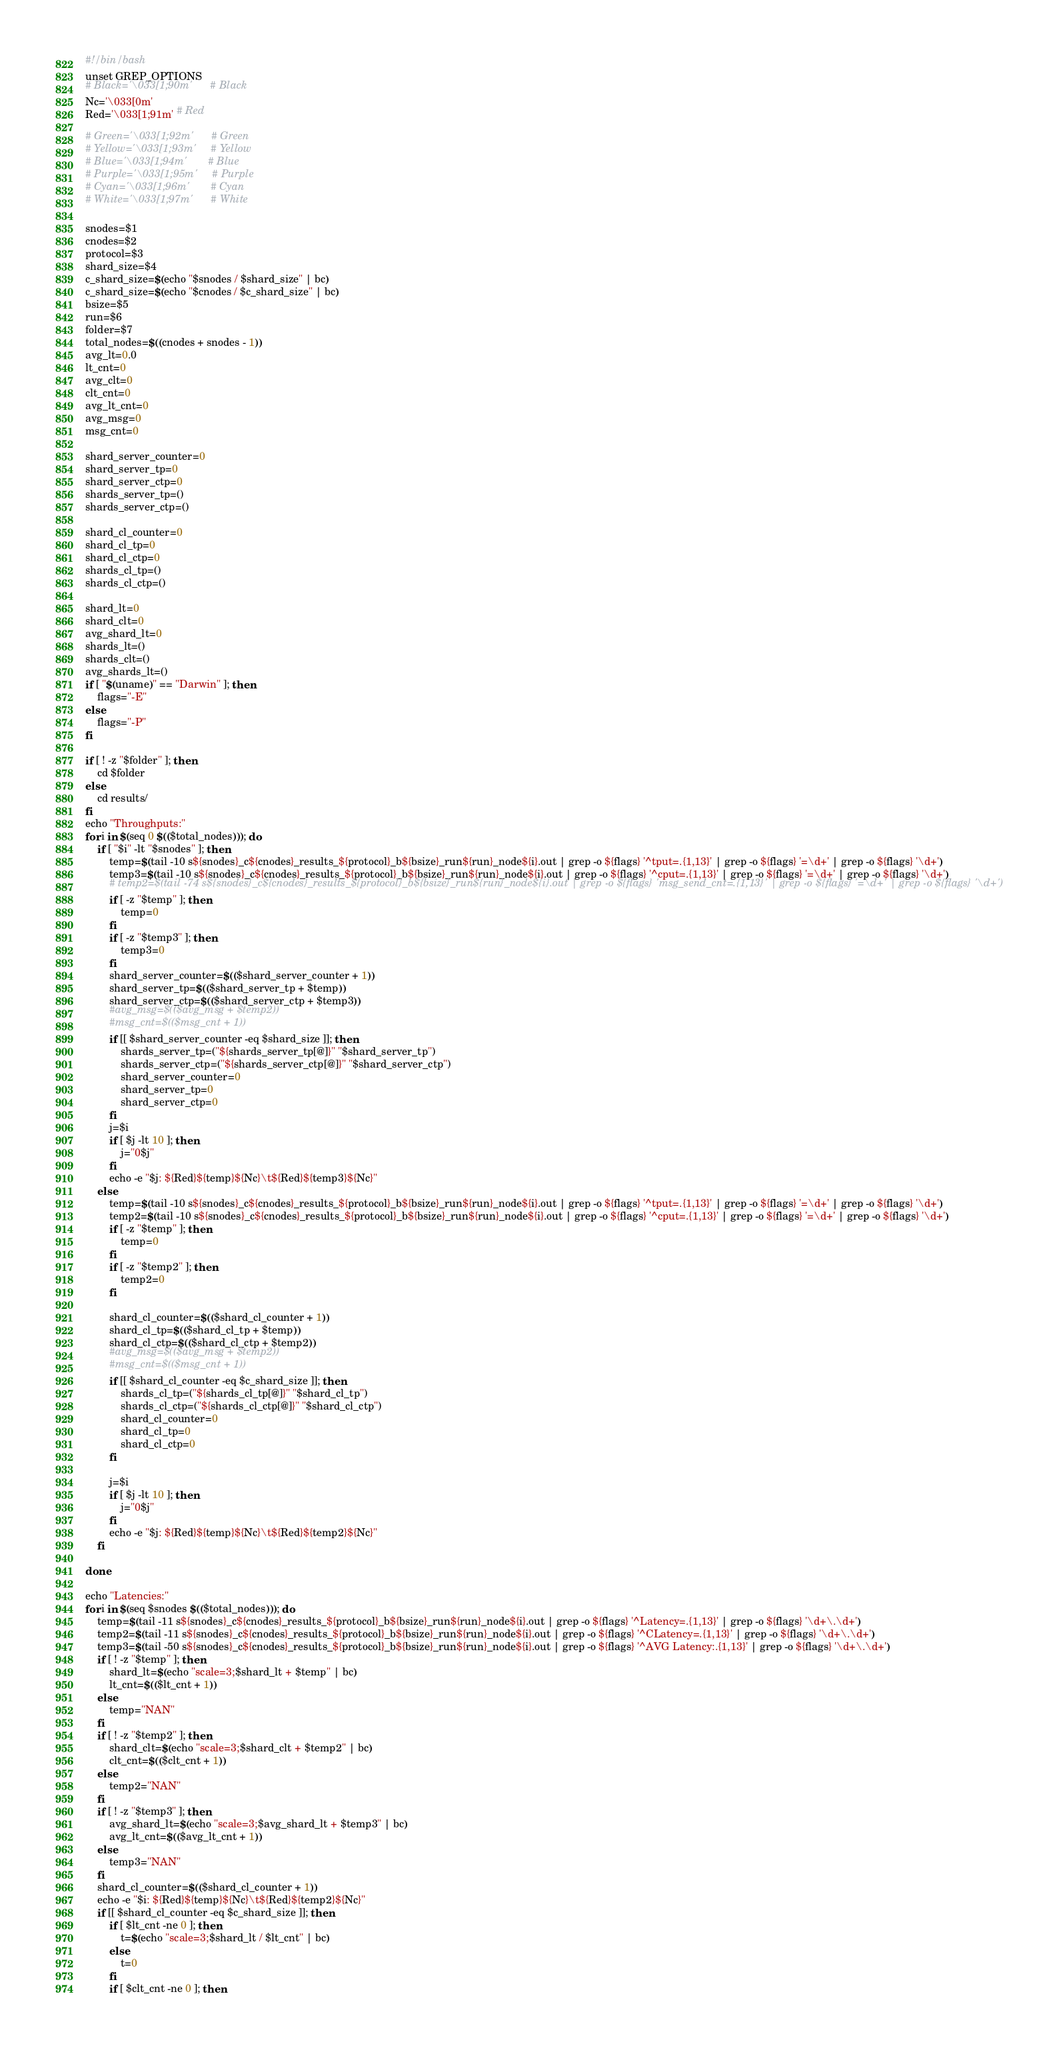Convert code to text. <code><loc_0><loc_0><loc_500><loc_500><_Bash_>#!/bin/bash
unset GREP_OPTIONS
# Black='\033[1;90m'      # Black
Nc='\033[0m'
Red='\033[1;91m' # Red

# Green='\033[1;92m'      # Green
# Yellow='\033[1;93m'     # Yellow
# Blue='\033[1;94m'       # Blue
# Purple='\033[1;95m'     # Purple
# Cyan='\033[1;96m'       # Cyan
# White='\033[1;97m'	  # White

snodes=$1
cnodes=$2
protocol=$3
shard_size=$4
c_shard_size=$(echo "$snodes / $shard_size" | bc)
c_shard_size=$(echo "$cnodes / $c_shard_size" | bc)
bsize=$5
run=$6
folder=$7
total_nodes=$((cnodes + snodes - 1))
avg_lt=0.0
lt_cnt=0
avg_clt=0
clt_cnt=0
avg_lt_cnt=0
avg_msg=0
msg_cnt=0

shard_server_counter=0
shard_server_tp=0
shard_server_ctp=0
shards_server_tp=()
shards_server_ctp=()

shard_cl_counter=0
shard_cl_tp=0
shard_cl_ctp=0
shards_cl_tp=()
shards_cl_ctp=()

shard_lt=0
shard_clt=0
avg_shard_lt=0
shards_lt=()
shards_clt=()
avg_shards_lt=()
if [ "$(uname)" == "Darwin" ]; then
	flags="-E"
else
	flags="-P"
fi

if [ ! -z "$folder" ]; then
	cd $folder
else
	cd results/
fi
echo "Throughputs:"
for i in $(seq 0 $(($total_nodes))); do
	if [ "$i" -lt "$snodes" ]; then
		temp=$(tail -10 s${snodes}_c${cnodes}_results_${protocol}_b${bsize}_run${run}_node${i}.out | grep -o ${flags} '^tput=.{1,13}' | grep -o ${flags} '=\d+' | grep -o ${flags} '\d+')
		temp3=$(tail -10 s${snodes}_c${cnodes}_results_${protocol}_b${bsize}_run${run}_node${i}.out | grep -o ${flags} '^cput=.{1,13}' | grep -o ${flags} '=\d+' | grep -o ${flags} '\d+')
		# temp2=$(tail -74 s${snodes}_c${cnodes}_results_${protocol}_b${bsize}_run${run}_node${i}.out | grep -o ${flags} 'msg_send_cnt=.{1,13}' | grep -o ${flags} '=\d+' | grep -o ${flags} '\d+')
		if [ -z "$temp" ]; then
			temp=0
		fi
		if [ -z "$temp3" ]; then
			temp3=0
		fi
		shard_server_counter=$(($shard_server_counter + 1))
		shard_server_tp=$(($shard_server_tp + $temp))
		shard_server_ctp=$(($shard_server_ctp + $temp3))
		#avg_msg=$(($avg_msg + $temp2))
		#msg_cnt=$(($msg_cnt + 1))
		if [[ $shard_server_counter -eq $shard_size ]]; then
			shards_server_tp=("${shards_server_tp[@]}" "$shard_server_tp")
			shards_server_ctp=("${shards_server_ctp[@]}" "$shard_server_ctp")
			shard_server_counter=0
			shard_server_tp=0
			shard_server_ctp=0
		fi
		j=$i
		if [ $j -lt 10 ]; then
			j="0$j"
		fi
		echo -e "$j: ${Red}${temp}${Nc}\t${Red}${temp3}${Nc}"
	else
		temp=$(tail -10 s${snodes}_c${cnodes}_results_${protocol}_b${bsize}_run${run}_node${i}.out | grep -o ${flags} '^tput=.{1,13}' | grep -o ${flags} '=\d+' | grep -o ${flags} '\d+')
		temp2=$(tail -10 s${snodes}_c${cnodes}_results_${protocol}_b${bsize}_run${run}_node${i}.out | grep -o ${flags} '^cput=.{1,13}' | grep -o ${flags} '=\d+' | grep -o ${flags} '\d+')
		if [ -z "$temp" ]; then
			temp=0
		fi
		if [ -z "$temp2" ]; then
			temp2=0
		fi

		shard_cl_counter=$(($shard_cl_counter + 1))
		shard_cl_tp=$(($shard_cl_tp + $temp))
		shard_cl_ctp=$(($shard_cl_ctp + $temp2))
		#avg_msg=$(($avg_msg + $temp2))
		#msg_cnt=$(($msg_cnt + 1))
		if [[ $shard_cl_counter -eq $c_shard_size ]]; then
			shards_cl_tp=("${shards_cl_tp[@]}" "$shard_cl_tp")
			shards_cl_ctp=("${shards_cl_ctp[@]}" "$shard_cl_ctp")
			shard_cl_counter=0
			shard_cl_tp=0
			shard_cl_ctp=0
		fi

		j=$i
		if [ $j -lt 10 ]; then
			j="0$j"
		fi
		echo -e "$j: ${Red}${temp}${Nc}\t${Red}${temp2}${Nc}"
	fi

done

echo "Latencies:"
for i in $(seq $snodes $(($total_nodes))); do
	temp=$(tail -11 s${snodes}_c${cnodes}_results_${protocol}_b${bsize}_run${run}_node${i}.out | grep -o ${flags} '^Latency=.{1,13}' | grep -o ${flags} '\d+\.\d+')
	temp2=$(tail -11 s${snodes}_c${cnodes}_results_${protocol}_b${bsize}_run${run}_node${i}.out | grep -o ${flags} '^CLatency=.{1,13}' | grep -o ${flags} '\d+\.\d+')
	temp3=$(tail -50 s${snodes}_c${cnodes}_results_${protocol}_b${bsize}_run${run}_node${i}.out | grep -o ${flags} '^AVG Latency:.{1,13}' | grep -o ${flags} '\d+\.\d+')
	if [ ! -z "$temp" ]; then
		shard_lt=$(echo "scale=3;$shard_lt + $temp" | bc)
		lt_cnt=$(($lt_cnt + 1))
	else
		temp="NAN"
	fi
	if [ ! -z "$temp2" ]; then
		shard_clt=$(echo "scale=3;$shard_clt + $temp2" | bc)
		clt_cnt=$(($clt_cnt + 1))
	else
		temp2="NAN"
	fi
	if [ ! -z "$temp3" ]; then
		avg_shard_lt=$(echo "scale=3;$avg_shard_lt + $temp3" | bc)
		avg_lt_cnt=$(($avg_lt_cnt + 1))
	else
		temp3="NAN"
	fi
	shard_cl_counter=$(($shard_cl_counter + 1))
	echo -e "$i: ${Red}${temp}${Nc}\t${Red}${temp2}${Nc}"
	if [[ $shard_cl_counter -eq $c_shard_size ]]; then
		if [ $lt_cnt -ne 0 ]; then
			t=$(echo "scale=3;$shard_lt / $lt_cnt" | bc)
		else
			t=0
		fi
		if [ $clt_cnt -ne 0 ]; then</code> 